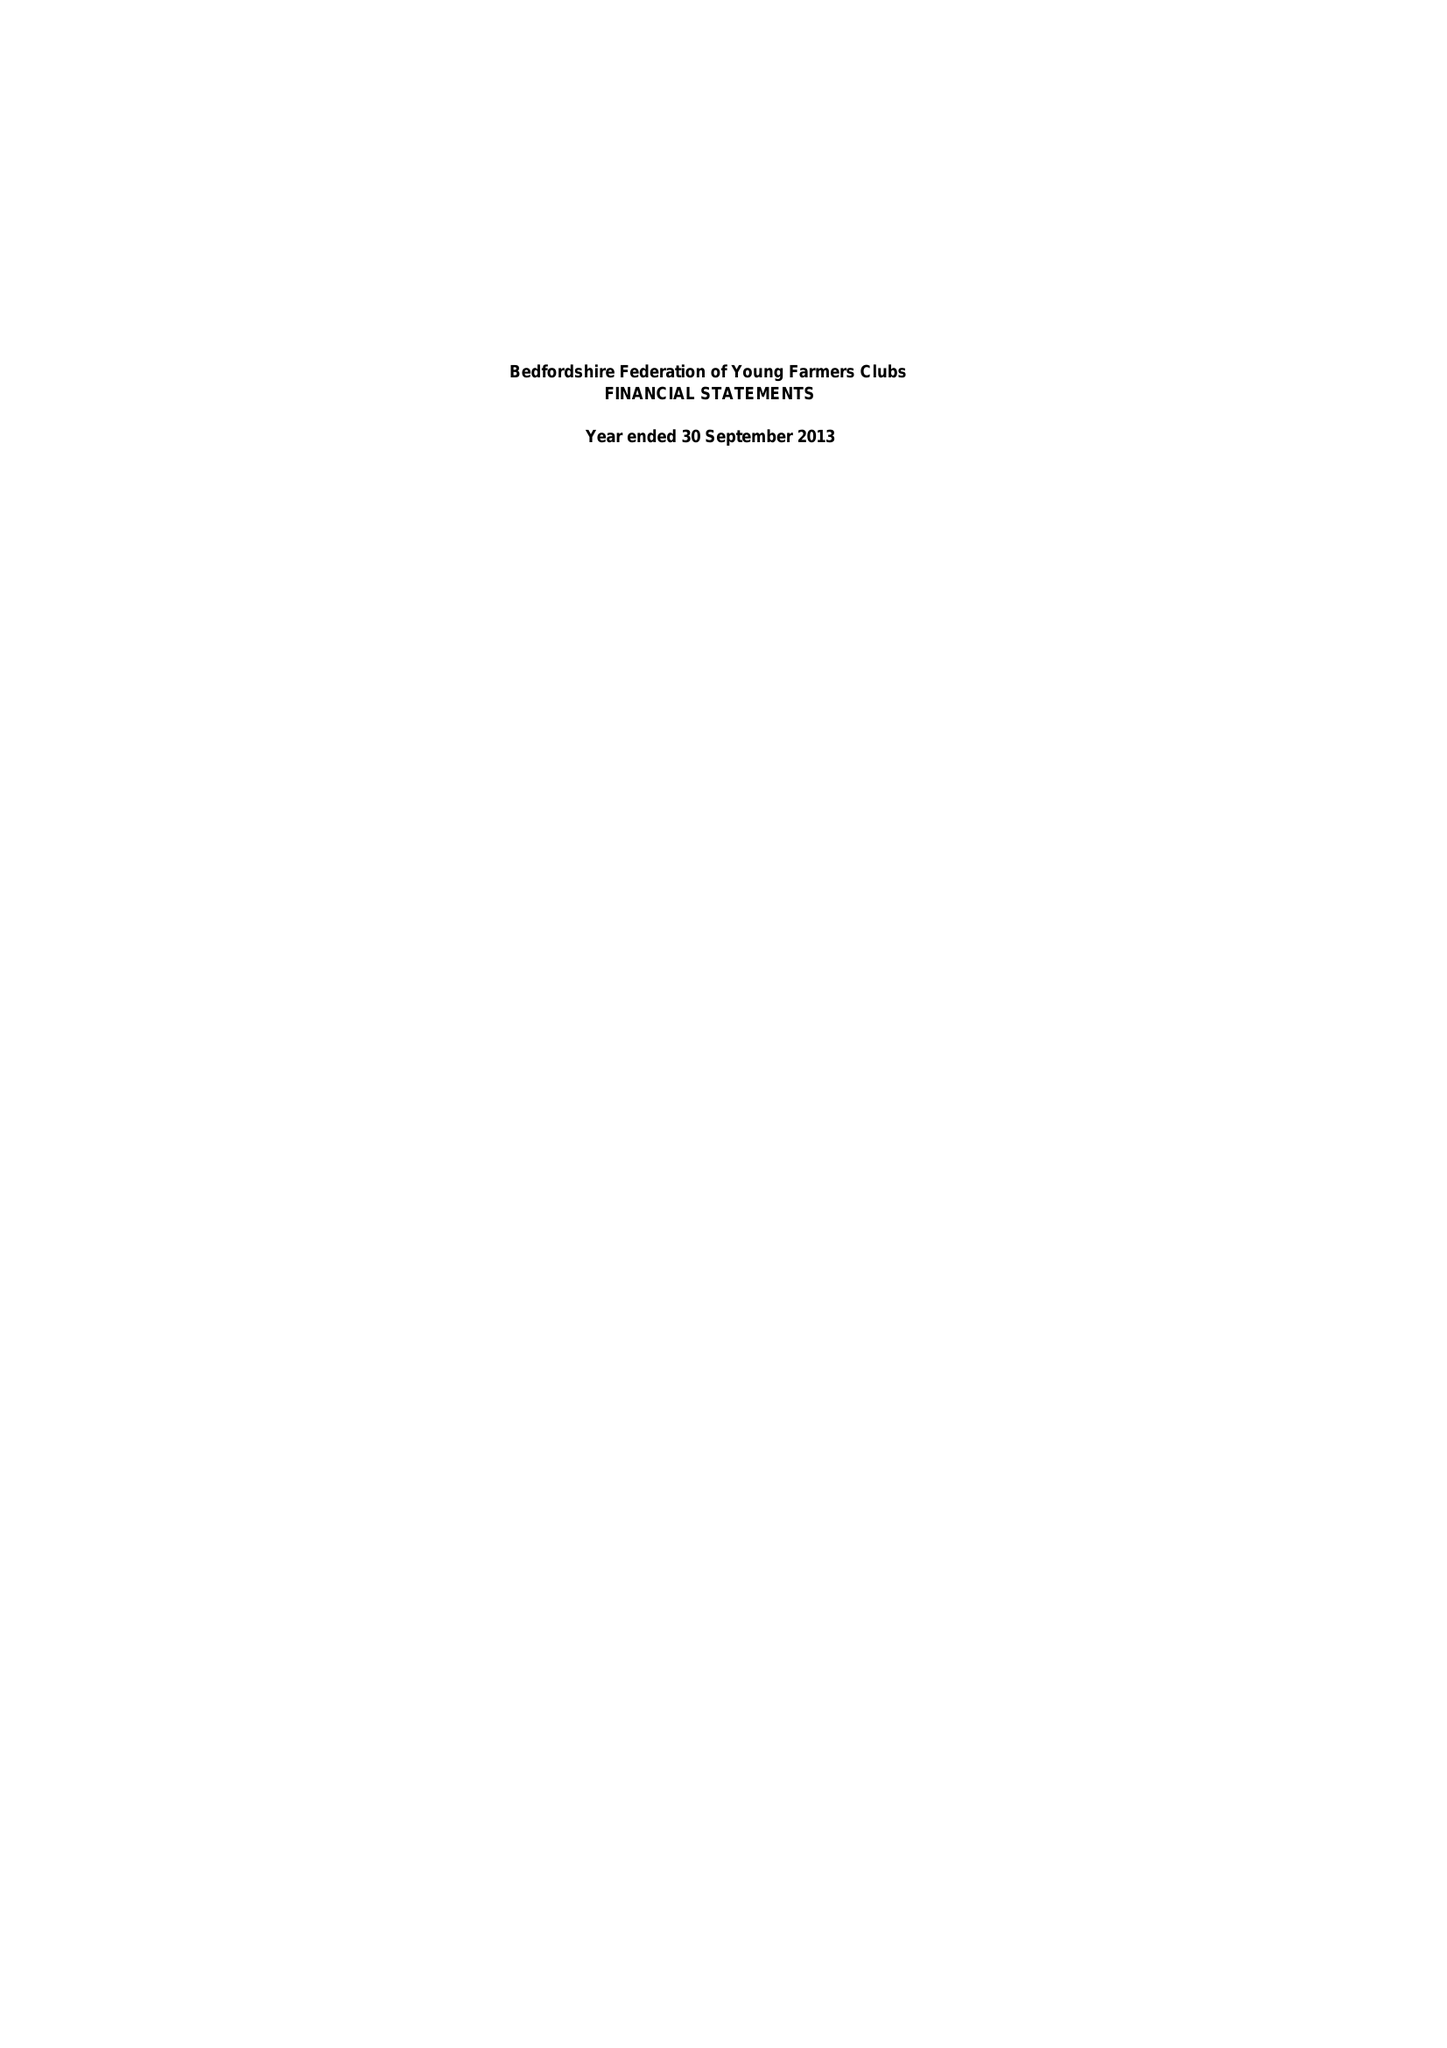What is the value for the income_annually_in_british_pounds?
Answer the question using a single word or phrase. 62982.34 